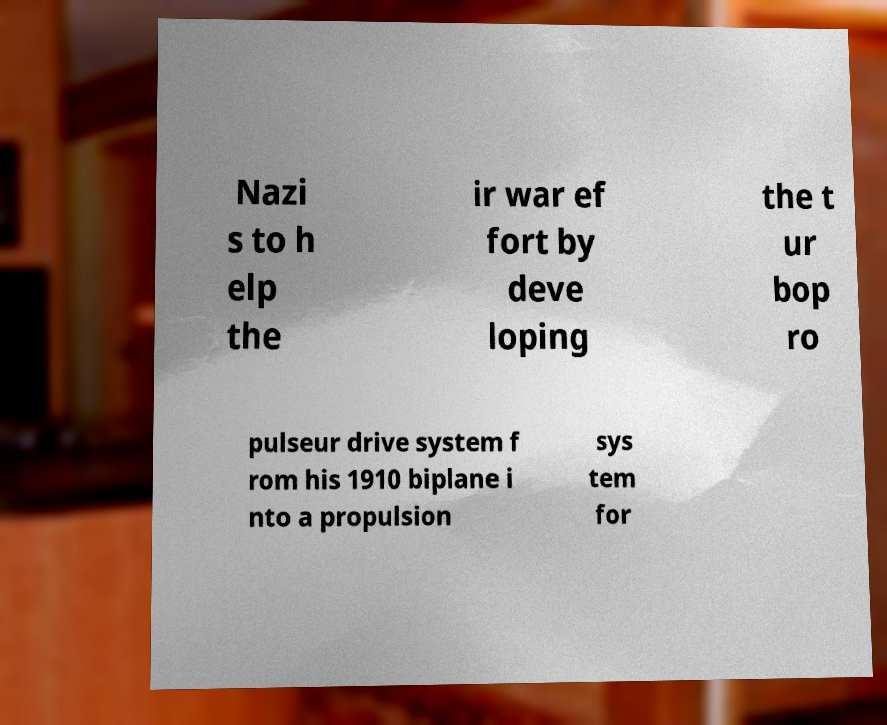Please read and relay the text visible in this image. What does it say? Nazi s to h elp the ir war ef fort by deve loping the t ur bop ro pulseur drive system f rom his 1910 biplane i nto a propulsion sys tem for 